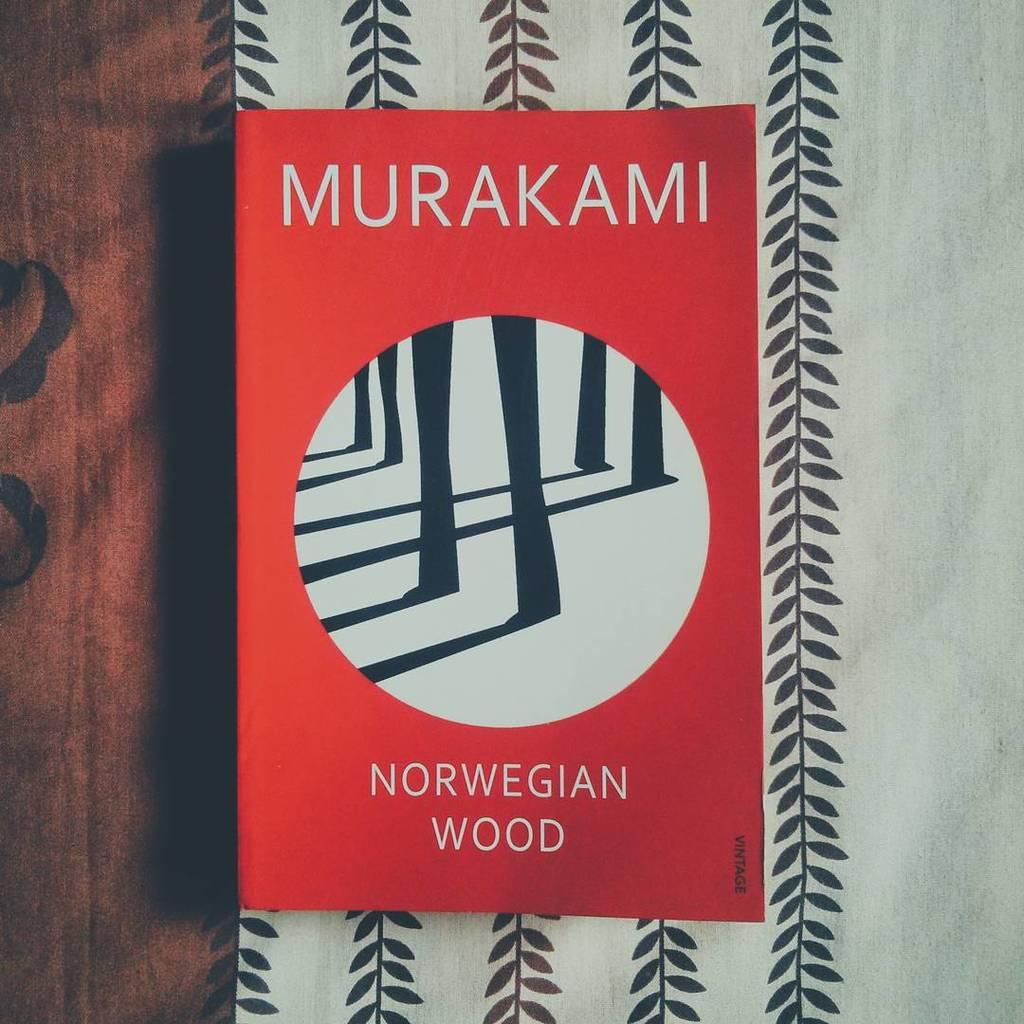<image>
Present a compact description of the photo's key features. The book Norwegian Wood by Murakami sits on a white cloth with vines. 